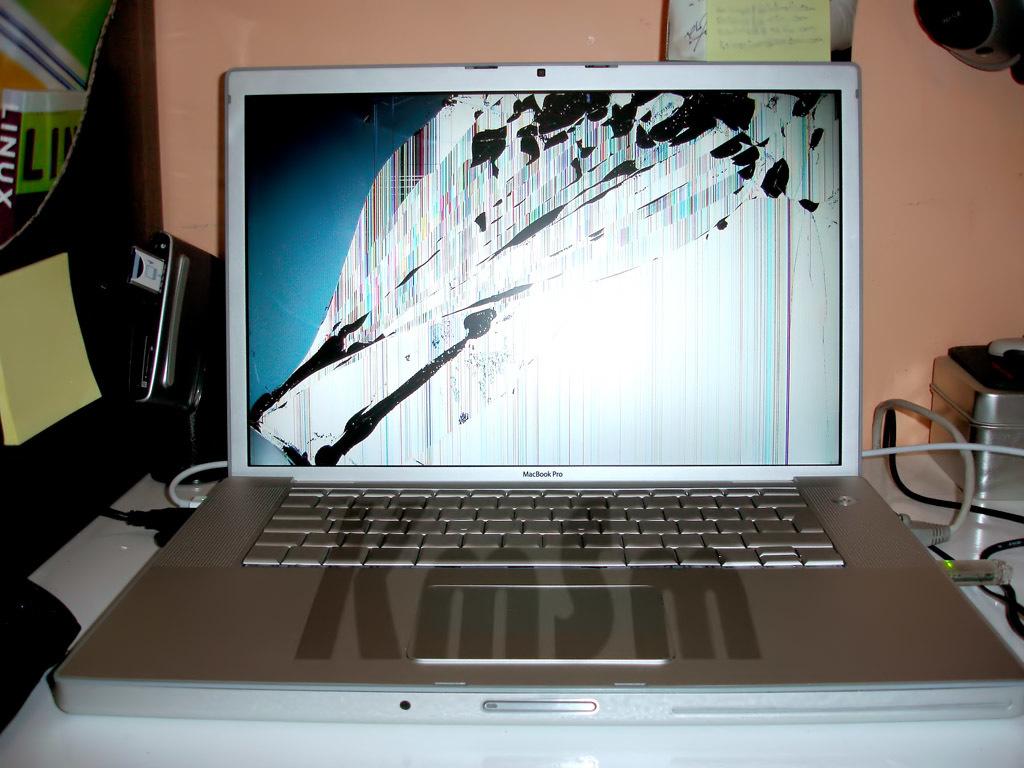What is the brand of laptop here?
Your answer should be very brief. Macbook pro. 